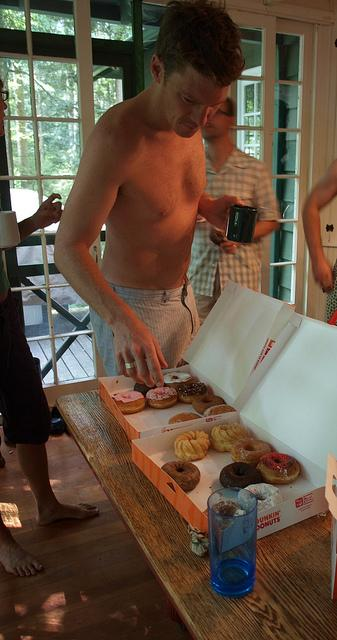What color is the icing on the top of the donuts underneath of the man's hand who is looking to eat?

Choices:
A) pink
B) black
C) red
D) white pink 